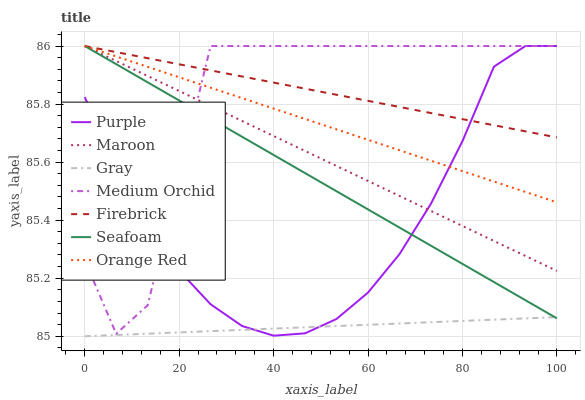Does Gray have the minimum area under the curve?
Answer yes or no. Yes. Does Firebrick have the maximum area under the curve?
Answer yes or no. Yes. Does Purple have the minimum area under the curve?
Answer yes or no. No. Does Purple have the maximum area under the curve?
Answer yes or no. No. Is Gray the smoothest?
Answer yes or no. Yes. Is Medium Orchid the roughest?
Answer yes or no. Yes. Is Purple the smoothest?
Answer yes or no. No. Is Purple the roughest?
Answer yes or no. No. Does Gray have the lowest value?
Answer yes or no. Yes. Does Purple have the lowest value?
Answer yes or no. No. Does Orange Red have the highest value?
Answer yes or no. Yes. Is Gray less than Maroon?
Answer yes or no. Yes. Is Maroon greater than Gray?
Answer yes or no. Yes. Does Purple intersect Firebrick?
Answer yes or no. Yes. Is Purple less than Firebrick?
Answer yes or no. No. Is Purple greater than Firebrick?
Answer yes or no. No. Does Gray intersect Maroon?
Answer yes or no. No. 